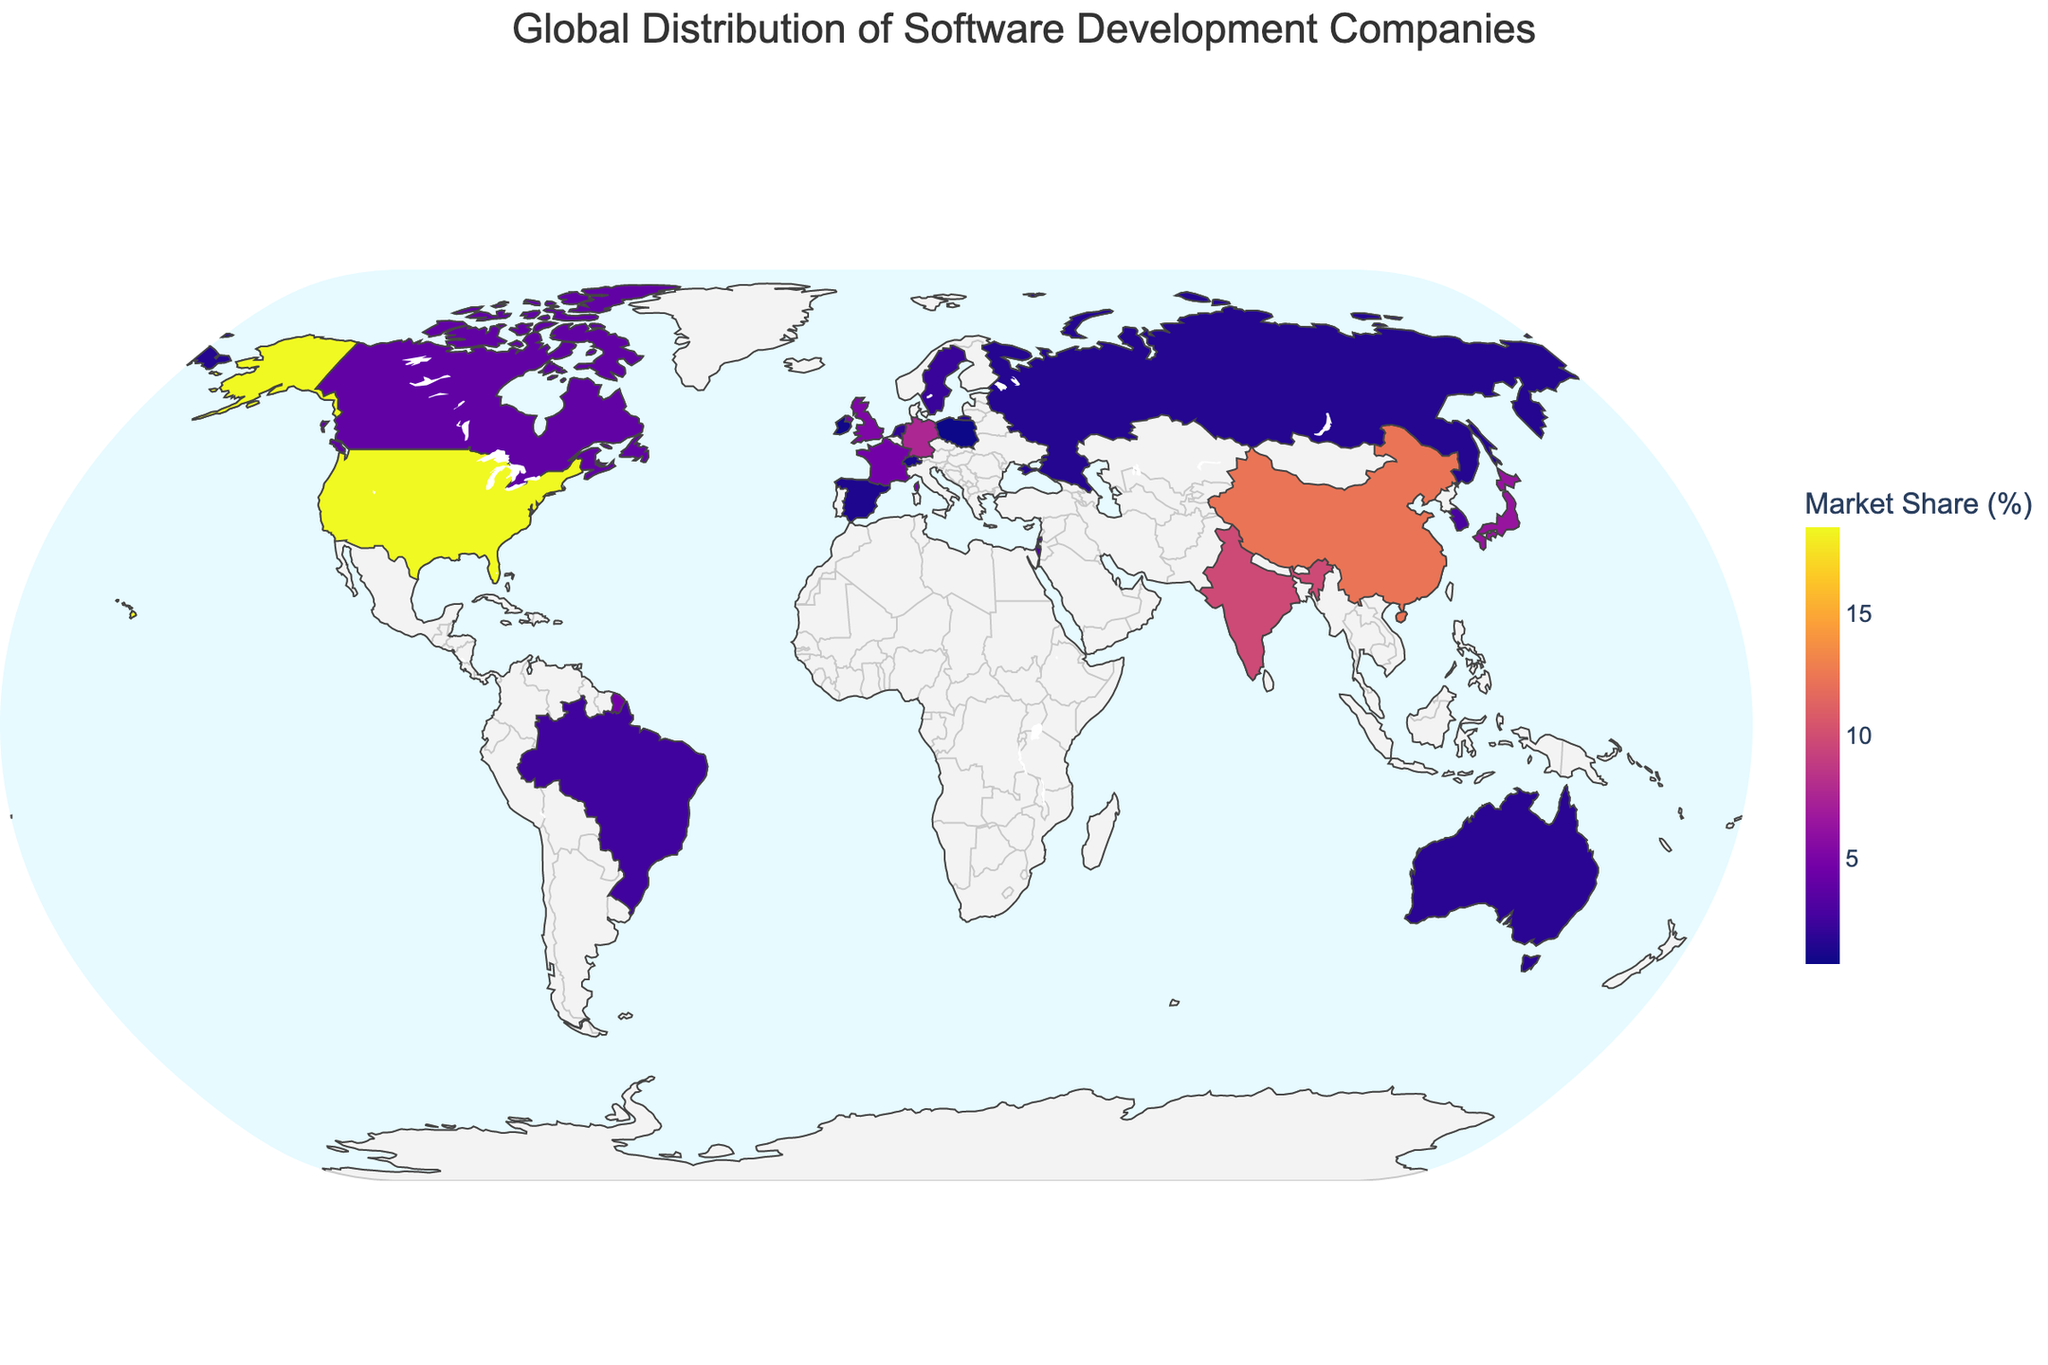which country has the highest market share? The country with the highest market share can be identified by looking at the color intensity or the size of the marker for each country. The darkest color and largest marker correspond to the United States with Microsoft, which has an 18.5% market share.
Answer: United States what is the total market share of Indian and Chinese companies? To find the total market share of Indian and Chinese companies, sum the market shares of Tata Consultancy Services in India (9.8%) and Alibaba in China (12.3%). The calculation is 9.8% + 12.3% = 22.1%.
Answer: 22.1% which companies have a market share greater than 5%? Companies with a market share greater than 5% are indicated by larger and darker markers. From the figure, these companies are Microsoft (18.5%), Alibaba (12.3%), Tata Consultancy Services (9.8%), SAP (7.6%), and Fujitsu (6.4%).
Answer: Microsoft, Alibaba, Tata Consultancy Services, SAP, Fujitsu which country has the smallest market share and what is the value? The country with the smallest market share will have the lightest color and the smallest marker. Singapore with Sea Limited has the smallest market share at 0.9%.
Answer: Singapore, 0.9% how much larger is the market share of Microsoft compared to Shopify? To find how much larger Microsoft's market share is compared to Shopify's, subtract Shopify's market share (3.9%) from Microsoft's market share (18.5%). The calculation is 18.5% - 3.9% = 14.6%.
Answer: 14.6% how many companies have a market share between 1% and 5%? Counting the companies that fall within the 1% to 5% range involves checking the markers in that color range and size. These companies are Dassault Systemes (4.7%), Shopify (3.9%), Check Point (3.1%), Samsung SDS (2.8%), TOTVS (2.5%), Ericsson (2.2%), Adyen (1.9%), Atlassian (1.7%), Kaspersky Lab (1.5%), Indra Sistemas (1.3%), and Avaloq (1.1%), totaling 11 companies.
Answer: 11 which company is represented by the largest marker in the plot? The largest marker in the plot represents the company with the highest market share, which is Microsoft from the United States.
Answer: Microsoft do European countries collectively have a larger market share than the United States? To determine this, sum the market shares of companies in European countries: SAP (7.6%), Sage Group (5.2%), Dassault Systemes (4.7%), Ericsson (2.2%), Adyen (1.9%), Kaspersky Lab (1.5%), Indra Sistemas (1.3%), Avaloq (1.1%), and Comarch (0.7%). The total is 7.6% + 5.2% + 4.7% + 2.2% + 1.9% + 1.5% + 1.3% + 1.1% + 0.7% = 26.2%, which is larger than the market share of the United States (18.5%).
Answer: Yes 